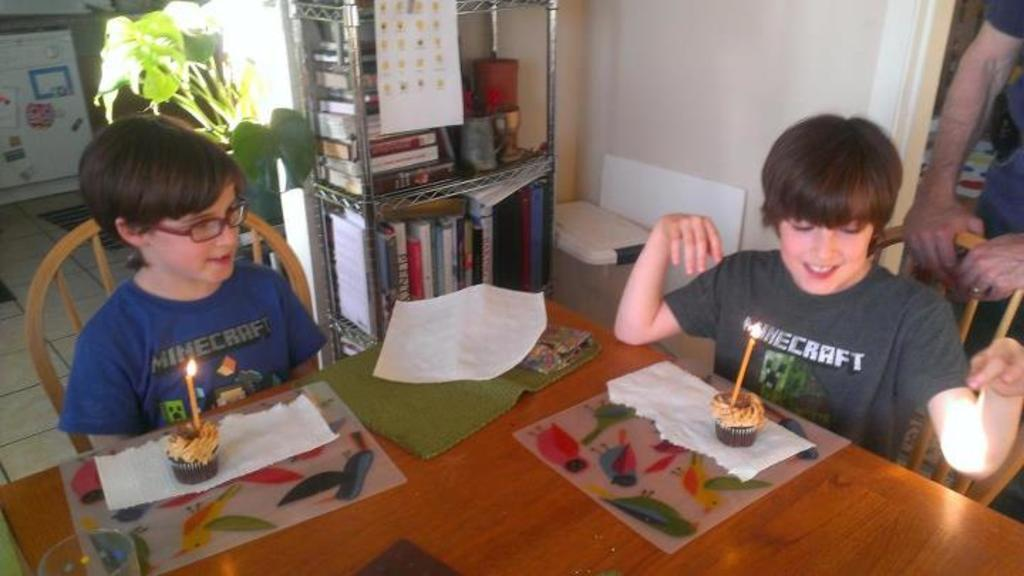How many people are in the image? There are two boys in the image. What are the boys doing in the image? The boys are sitting on a chair. What is in front of the boys? There is a cake in front of the boys. Where is the cake placed? The cake is on a table. What type of winter game are the boys playing in the image? There is no winter game being played in the image; the boys are sitting on a chair with a cake in front of them. 